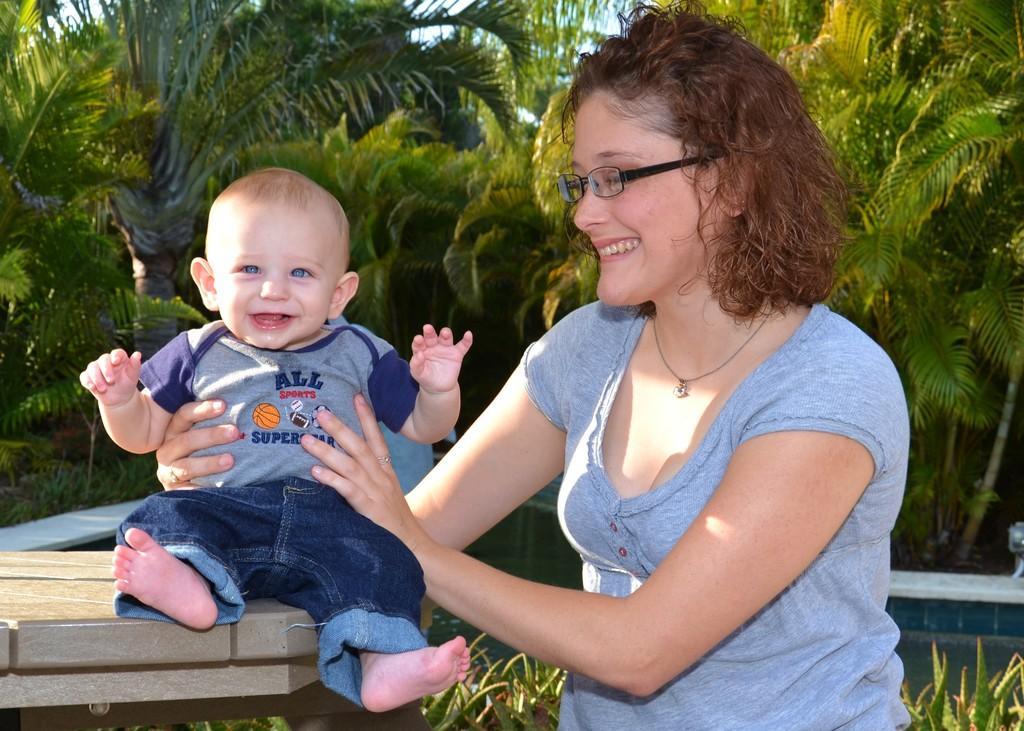Can you describe this image briefly? As we can see in the image in the front there are two people, table and plants. In the background there are trees. 